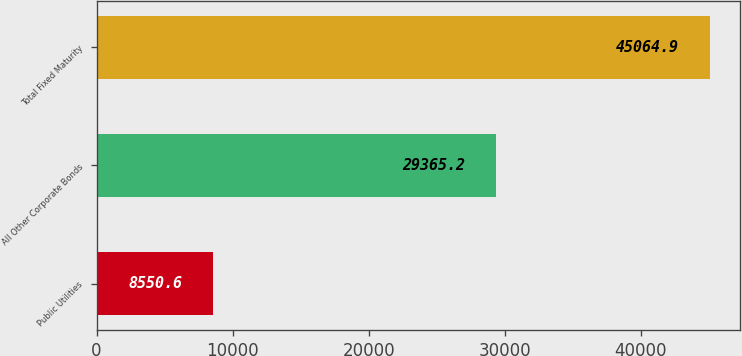<chart> <loc_0><loc_0><loc_500><loc_500><bar_chart><fcel>Public Utilities<fcel>All Other Corporate Bonds<fcel>Total Fixed Maturity<nl><fcel>8550.6<fcel>29365.2<fcel>45064.9<nl></chart> 